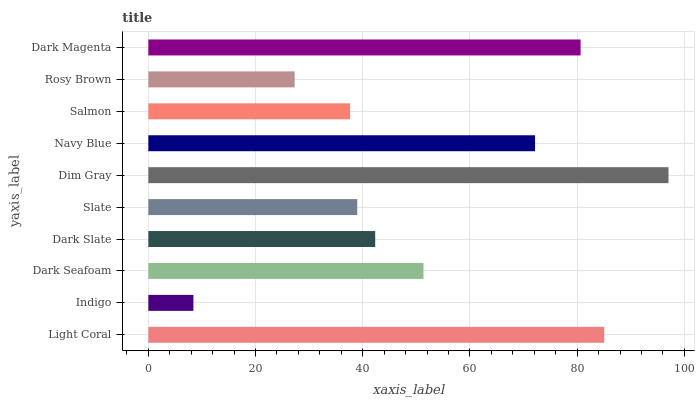Is Indigo the minimum?
Answer yes or no. Yes. Is Dim Gray the maximum?
Answer yes or no. Yes. Is Dark Seafoam the minimum?
Answer yes or no. No. Is Dark Seafoam the maximum?
Answer yes or no. No. Is Dark Seafoam greater than Indigo?
Answer yes or no. Yes. Is Indigo less than Dark Seafoam?
Answer yes or no. Yes. Is Indigo greater than Dark Seafoam?
Answer yes or no. No. Is Dark Seafoam less than Indigo?
Answer yes or no. No. Is Dark Seafoam the high median?
Answer yes or no. Yes. Is Dark Slate the low median?
Answer yes or no. Yes. Is Navy Blue the high median?
Answer yes or no. No. Is Navy Blue the low median?
Answer yes or no. No. 